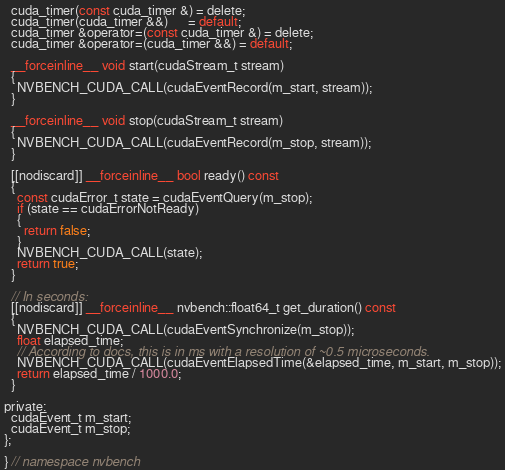Convert code to text. <code><loc_0><loc_0><loc_500><loc_500><_Cuda_>  cuda_timer(const cuda_timer &) = delete;
  cuda_timer(cuda_timer &&)      = default;
  cuda_timer &operator=(const cuda_timer &) = delete;
  cuda_timer &operator=(cuda_timer &&) = default;

  __forceinline__ void start(cudaStream_t stream)
  {
    NVBENCH_CUDA_CALL(cudaEventRecord(m_start, stream));
  }

  __forceinline__ void stop(cudaStream_t stream)
  {
    NVBENCH_CUDA_CALL(cudaEventRecord(m_stop, stream));
  }

  [[nodiscard]] __forceinline__ bool ready() const
  {
    const cudaError_t state = cudaEventQuery(m_stop);
    if (state == cudaErrorNotReady)
    {
      return false;
    }
    NVBENCH_CUDA_CALL(state);
    return true;
  }

  // In seconds:
  [[nodiscard]] __forceinline__ nvbench::float64_t get_duration() const
  {
    NVBENCH_CUDA_CALL(cudaEventSynchronize(m_stop));
    float elapsed_time;
    // According to docs, this is in ms with a resolution of ~0.5 microseconds.
    NVBENCH_CUDA_CALL(cudaEventElapsedTime(&elapsed_time, m_start, m_stop));
    return elapsed_time / 1000.0;
  }

private:
  cudaEvent_t m_start;
  cudaEvent_t m_stop;
};

} // namespace nvbench
</code> 